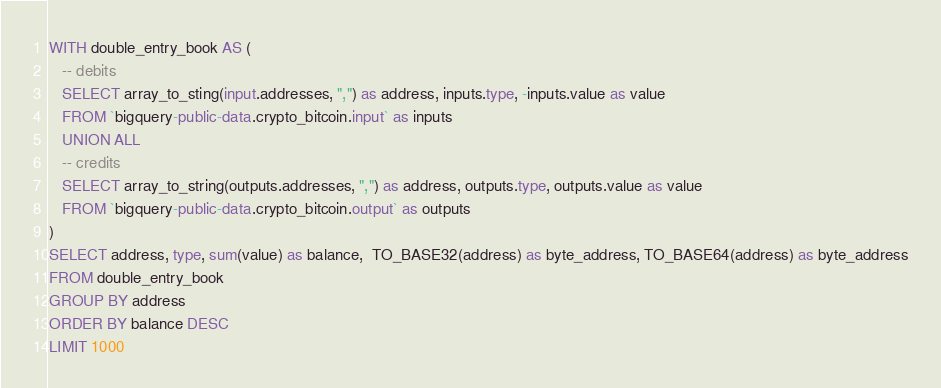<code> <loc_0><loc_0><loc_500><loc_500><_SQL_>WITH double_entry_book AS (
   -- debits
   SELECT array_to_sting(input.addresses, ",") as address, inputs.type, -inputs.value as value
   FROM `bigquery-public-data.crypto_bitcoin.input` as inputs
   UNION ALL
   -- credits
   SELECT array_to_string(outputs.addresses, ",") as address, outputs.type, outputs.value as value
   FROM `bigquery-public-data.crypto_bitcoin.output` as outputs
)
SELECT address, type, sum(value) as balance,  TO_BASE32(address) as byte_address, TO_BASE64(address) as byte_address
FROM double_entry_book
GROUP BY address
ORDER BY balance DESC
LIMIT 1000</code> 